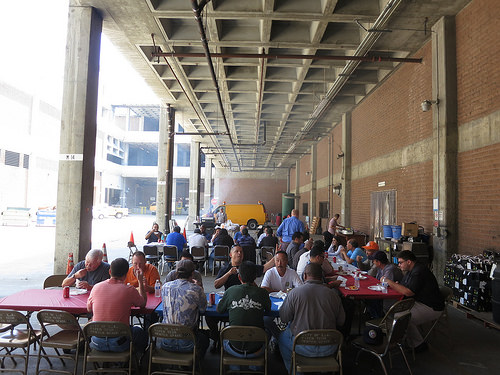<image>
Is the shirt on the man? No. The shirt is not positioned on the man. They may be near each other, but the shirt is not supported by or resting on top of the man. Is the table in front of the chair? Yes. The table is positioned in front of the chair, appearing closer to the camera viewpoint. 